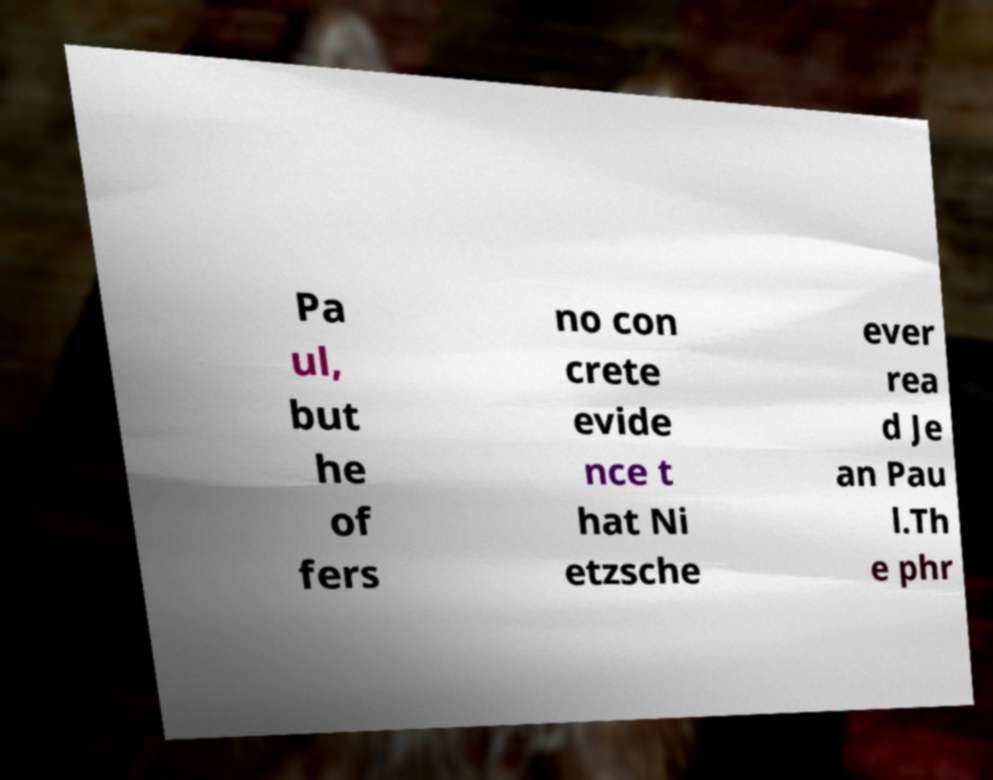Can you read and provide the text displayed in the image?This photo seems to have some interesting text. Can you extract and type it out for me? Pa ul, but he of fers no con crete evide nce t hat Ni etzsche ever rea d Je an Pau l.Th e phr 